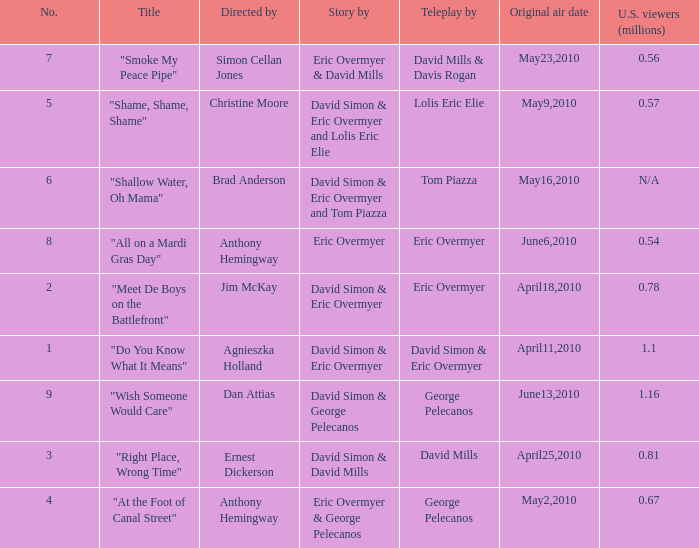Name the us viewers directed by christine moore 0.57. 